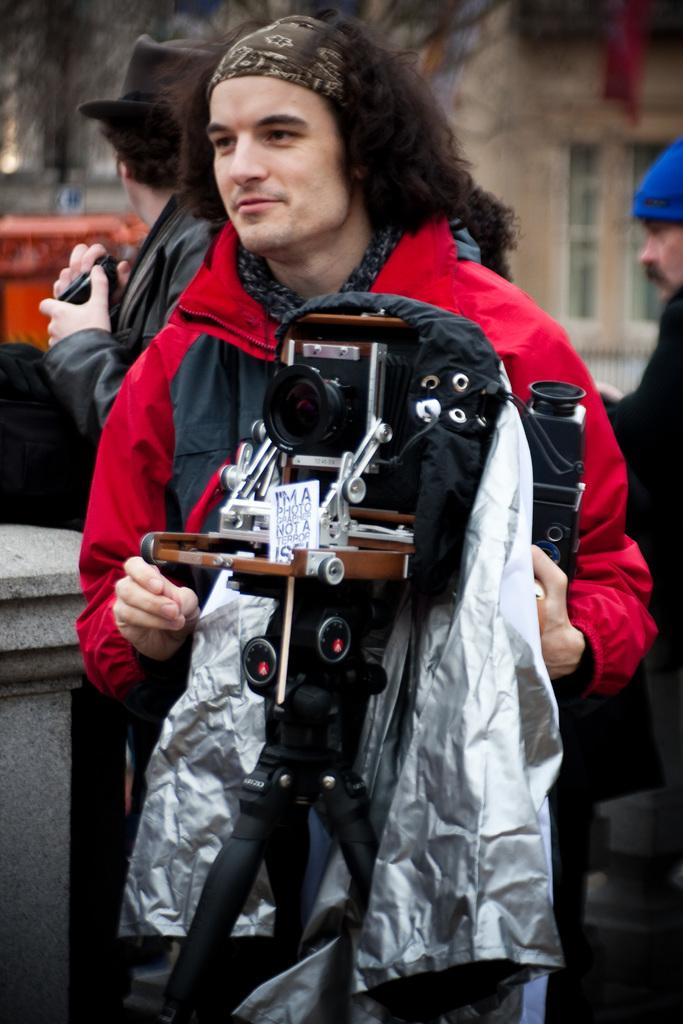What can be seen in the image regarding people? There are persons wearing clothes in the image. What is the main object in the middle of the image? There is a camera in the middle of the image. How would you describe the background of the image? The background of the image is blurred. How many jellyfish can be seen swimming in the background of the image? There are no jellyfish present in the image; the background is blurred. What type of muscle is being exercised by the persons in the image? There is no indication of any specific muscle being exercised in the image, as it primarily features persons wearing clothes and a camera. 